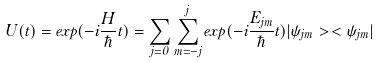Convert formula to latex. <formula><loc_0><loc_0><loc_500><loc_500>U ( t ) = e x p ( - i \frac { H } { \hbar } { t } ) = \sum _ { j = 0 } \sum _ { m = - j } ^ { j } e x p ( - i \frac { E _ { j m } } \hbar { t } ) | \psi _ { j m } > < \psi _ { j m } |</formula> 